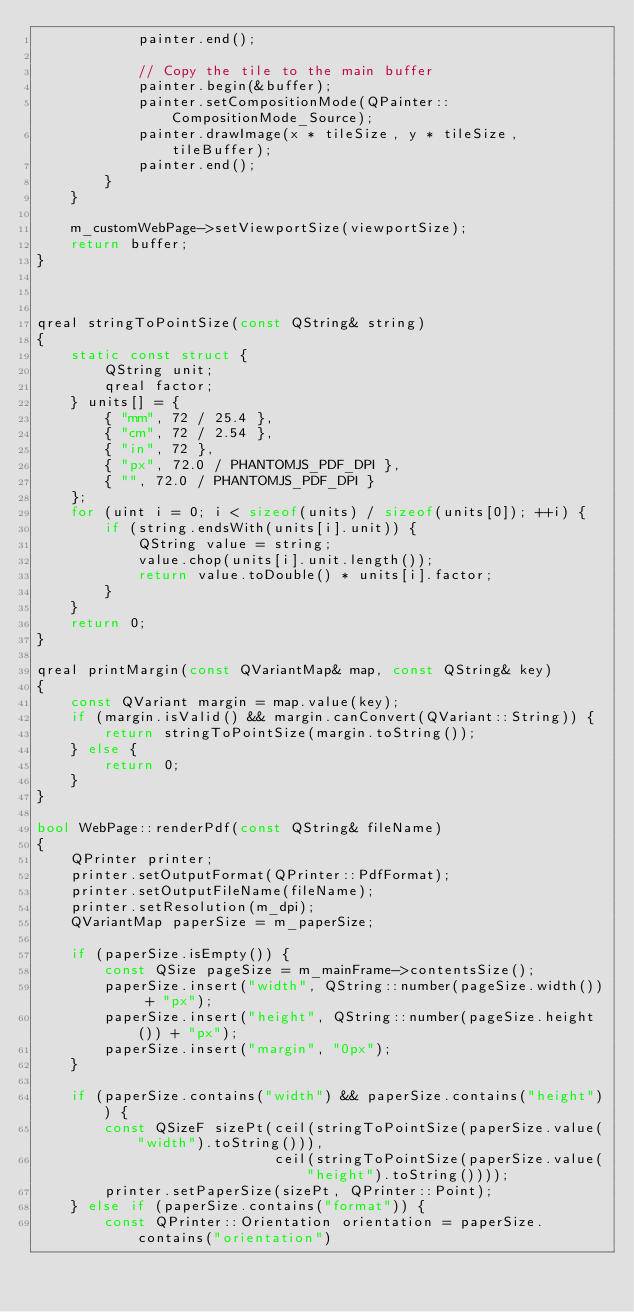<code> <loc_0><loc_0><loc_500><loc_500><_C++_>            painter.end();

            // Copy the tile to the main buffer
            painter.begin(&buffer);
            painter.setCompositionMode(QPainter::CompositionMode_Source);
            painter.drawImage(x * tileSize, y * tileSize, tileBuffer);
            painter.end();
        }
    }

    m_customWebPage->setViewportSize(viewportSize);
    return buffer;
}



qreal stringToPointSize(const QString& string)
{
    static const struct {
        QString unit;
        qreal factor;
    } units[] = {
        { "mm", 72 / 25.4 },
        { "cm", 72 / 2.54 },
        { "in", 72 },
        { "px", 72.0 / PHANTOMJS_PDF_DPI },
        { "", 72.0 / PHANTOMJS_PDF_DPI }
    };
    for (uint i = 0; i < sizeof(units) / sizeof(units[0]); ++i) {
        if (string.endsWith(units[i].unit)) {
            QString value = string;
            value.chop(units[i].unit.length());
            return value.toDouble() * units[i].factor;
        }
    }
    return 0;
}

qreal printMargin(const QVariantMap& map, const QString& key)
{
    const QVariant margin = map.value(key);
    if (margin.isValid() && margin.canConvert(QVariant::String)) {
        return stringToPointSize(margin.toString());
    } else {
        return 0;
    }
}

bool WebPage::renderPdf(const QString& fileName)
{
    QPrinter printer;
    printer.setOutputFormat(QPrinter::PdfFormat);
    printer.setOutputFileName(fileName);
    printer.setResolution(m_dpi);
    QVariantMap paperSize = m_paperSize;

    if (paperSize.isEmpty()) {
        const QSize pageSize = m_mainFrame->contentsSize();
        paperSize.insert("width", QString::number(pageSize.width()) + "px");
        paperSize.insert("height", QString::number(pageSize.height()) + "px");
        paperSize.insert("margin", "0px");
    }

    if (paperSize.contains("width") && paperSize.contains("height")) {
        const QSizeF sizePt(ceil(stringToPointSize(paperSize.value("width").toString())),
                            ceil(stringToPointSize(paperSize.value("height").toString())));
        printer.setPaperSize(sizePt, QPrinter::Point);
    } else if (paperSize.contains("format")) {
        const QPrinter::Orientation orientation = paperSize.contains("orientation")</code> 